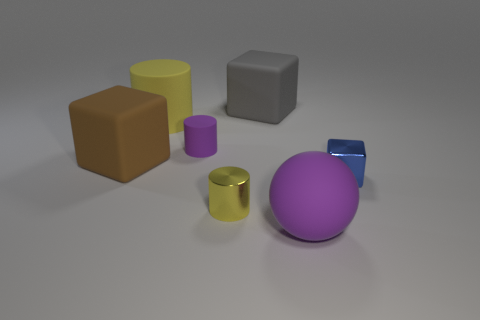There is a rubber thing that is the same color as the large matte ball; what size is it?
Your answer should be compact. Small. What number of big things are balls or purple cylinders?
Make the answer very short. 1. What is the material of the large yellow object?
Your answer should be compact. Rubber. There is a big object that is both in front of the yellow rubber cylinder and behind the matte ball; what material is it?
Give a very brief answer. Rubber. Is the color of the big matte cylinder the same as the large cube in front of the large yellow matte cylinder?
Your answer should be compact. No. There is a purple cylinder that is the same size as the blue metallic thing; what is its material?
Ensure brevity in your answer.  Rubber. Is there a yellow thing made of the same material as the gray object?
Ensure brevity in your answer.  Yes. What number of tiny yellow metal cylinders are there?
Your answer should be very brief. 1. Is the large brown cube made of the same material as the tiny cylinder that is in front of the large brown thing?
Your response must be concise. No. There is a small cylinder that is the same color as the large cylinder; what material is it?
Your answer should be compact. Metal. 